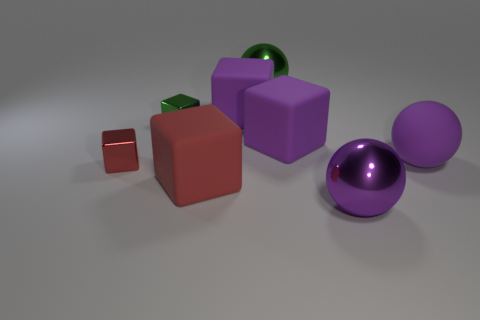What number of other things are the same color as the matte ball?
Your answer should be compact. 3. What is the material of the red cube that is on the right side of the small metallic thing on the left side of the green cube?
Your answer should be very brief. Rubber. Are there any blue shiny blocks?
Provide a short and direct response. No. There is a green cube that is left of the sphere that is in front of the big red thing; what is its size?
Offer a terse response. Small. Is the number of spheres behind the red rubber object greater than the number of purple metal objects right of the small green block?
Your answer should be compact. Yes. What number of cylinders are either big red things or matte objects?
Keep it short and to the point. 0. Is the shape of the small metallic thing that is right of the tiny red object the same as  the large purple shiny object?
Keep it short and to the point. No. What color is the rubber sphere?
Offer a very short reply. Purple. There is another metal thing that is the same shape as the big green thing; what is its color?
Make the answer very short. Purple. How many purple things are the same shape as the tiny red thing?
Your answer should be compact. 2. 